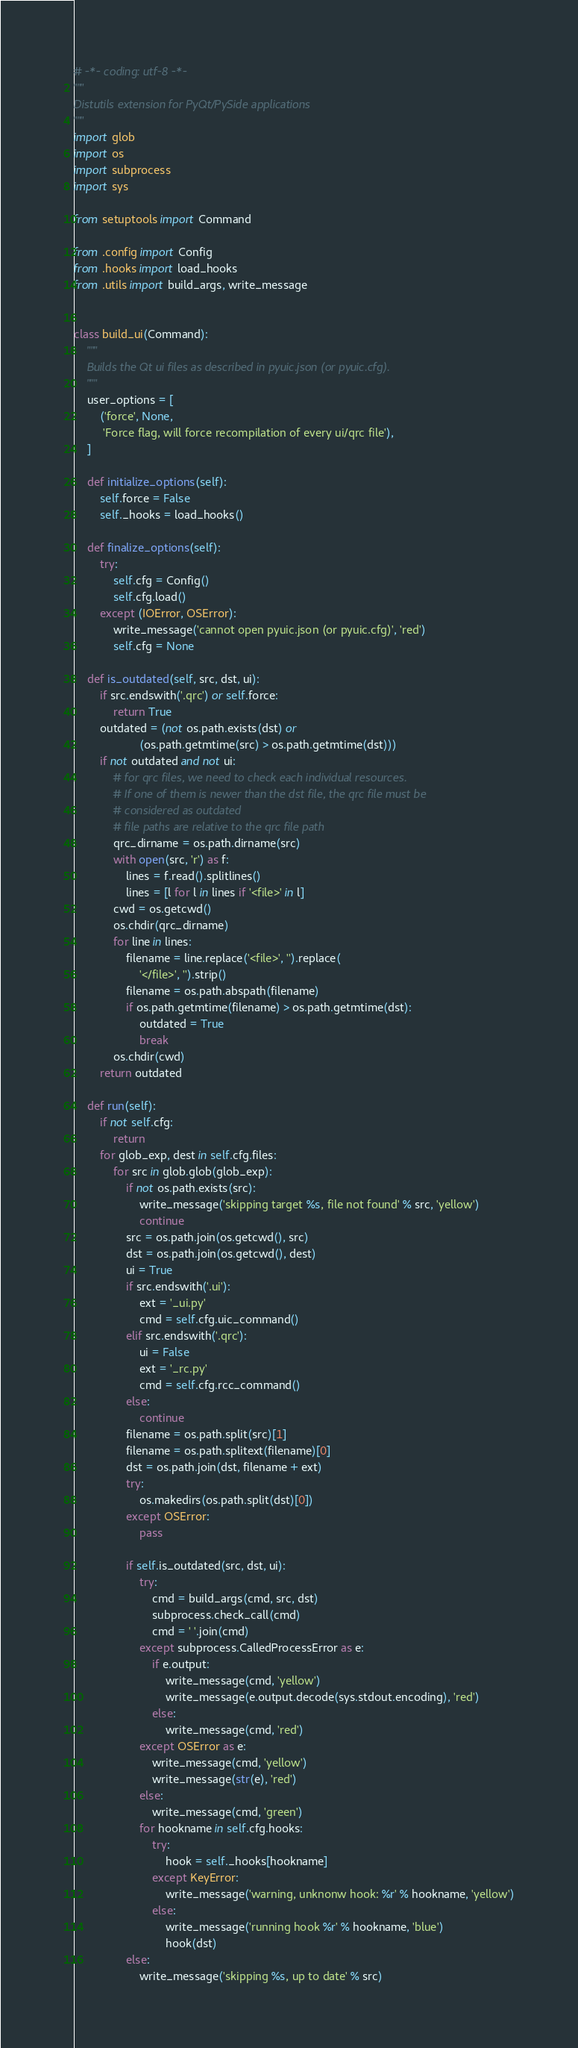Convert code to text. <code><loc_0><loc_0><loc_500><loc_500><_Python_># -*- coding: utf-8 -*-
"""
Distutils extension for PyQt/PySide applications
"""
import glob
import os
import subprocess
import sys

from setuptools import Command

from .config import Config
from .hooks import load_hooks
from .utils import build_args, write_message


class build_ui(Command):
    """
    Builds the Qt ui files as described in pyuic.json (or pyuic.cfg).
    """
    user_options = [
        ('force', None,
         'Force flag, will force recompilation of every ui/qrc file'),
    ]

    def initialize_options(self):
        self.force = False
        self._hooks = load_hooks()

    def finalize_options(self):
        try:
            self.cfg = Config()
            self.cfg.load()
        except (IOError, OSError):
            write_message('cannot open pyuic.json (or pyuic.cfg)', 'red')
            self.cfg = None

    def is_outdated(self, src, dst, ui):
        if src.endswith('.qrc') or self.force:
            return True
        outdated = (not os.path.exists(dst) or
                    (os.path.getmtime(src) > os.path.getmtime(dst)))
        if not outdated and not ui:
            # for qrc files, we need to check each individual resources.
            # If one of them is newer than the dst file, the qrc file must be
            # considered as outdated
            # file paths are relative to the qrc file path
            qrc_dirname = os.path.dirname(src)
            with open(src, 'r') as f:
                lines = f.read().splitlines()
                lines = [l for l in lines if '<file>' in l]
            cwd = os.getcwd()
            os.chdir(qrc_dirname)
            for line in lines:
                filename = line.replace('<file>', '').replace(
                    '</file>', '').strip()
                filename = os.path.abspath(filename)
                if os.path.getmtime(filename) > os.path.getmtime(dst):
                    outdated = True
                    break
            os.chdir(cwd)
        return outdated

    def run(self):
        if not self.cfg:
            return
        for glob_exp, dest in self.cfg.files:
            for src in glob.glob(glob_exp):
                if not os.path.exists(src):
                    write_message('skipping target %s, file not found' % src, 'yellow')
                    continue
                src = os.path.join(os.getcwd(), src)
                dst = os.path.join(os.getcwd(), dest)
                ui = True
                if src.endswith('.ui'):
                    ext = '_ui.py'
                    cmd = self.cfg.uic_command()
                elif src.endswith('.qrc'):
                    ui = False
                    ext = '_rc.py'
                    cmd = self.cfg.rcc_command()
                else:
                    continue
                filename = os.path.split(src)[1]
                filename = os.path.splitext(filename)[0]
                dst = os.path.join(dst, filename + ext)
                try:
                    os.makedirs(os.path.split(dst)[0])
                except OSError:
                    pass

                if self.is_outdated(src, dst, ui):
                    try:
                        cmd = build_args(cmd, src, dst)
                        subprocess.check_call(cmd)
                        cmd = ' '.join(cmd)
                    except subprocess.CalledProcessError as e:
                        if e.output:
                            write_message(cmd, 'yellow')
                            write_message(e.output.decode(sys.stdout.encoding), 'red')
                        else:
                            write_message(cmd, 'red')
                    except OSError as e:
                        write_message(cmd, 'yellow')
                        write_message(str(e), 'red')
                    else:
                        write_message(cmd, 'green')
                    for hookname in self.cfg.hooks:
                        try:
                            hook = self._hooks[hookname]
                        except KeyError:
                            write_message('warning, unknonw hook: %r' % hookname, 'yellow')
                        else:
                            write_message('running hook %r' % hookname, 'blue')
                            hook(dst)
                else:
                    write_message('skipping %s, up to date' % src)
</code> 